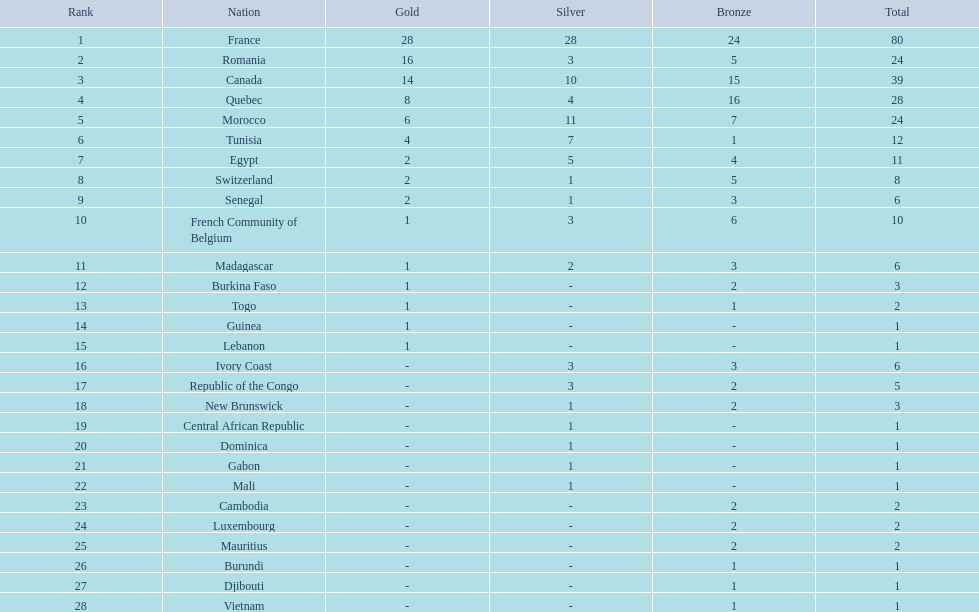What was the total medal count of switzerland? 8. 